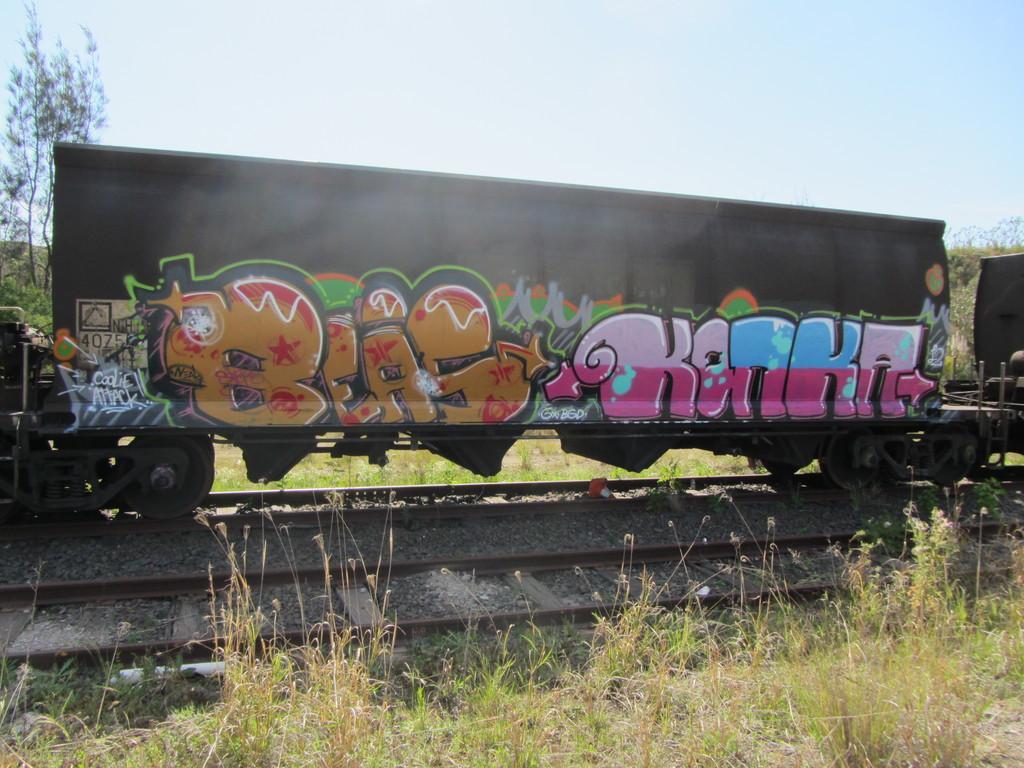Can you describe this image briefly? In this image I can see the train on the track. There is a colorful painting on the train. To the side of the train there is a grass and trees. In the background I can see the sky. 